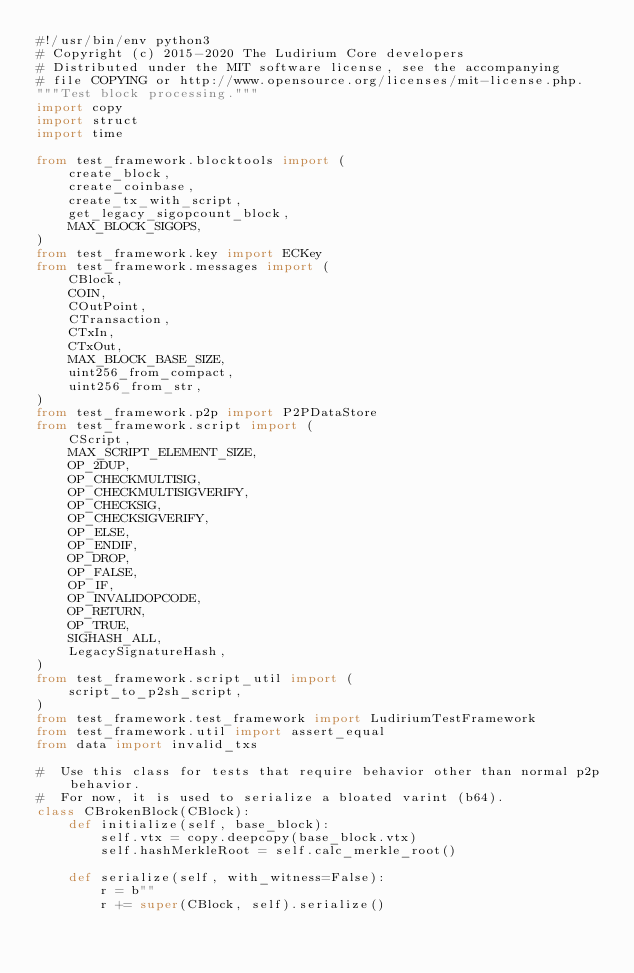<code> <loc_0><loc_0><loc_500><loc_500><_Python_>#!/usr/bin/env python3
# Copyright (c) 2015-2020 The Ludirium Core developers
# Distributed under the MIT software license, see the accompanying
# file COPYING or http://www.opensource.org/licenses/mit-license.php.
"""Test block processing."""
import copy
import struct
import time

from test_framework.blocktools import (
    create_block,
    create_coinbase,
    create_tx_with_script,
    get_legacy_sigopcount_block,
    MAX_BLOCK_SIGOPS,
)
from test_framework.key import ECKey
from test_framework.messages import (
    CBlock,
    COIN,
    COutPoint,
    CTransaction,
    CTxIn,
    CTxOut,
    MAX_BLOCK_BASE_SIZE,
    uint256_from_compact,
    uint256_from_str,
)
from test_framework.p2p import P2PDataStore
from test_framework.script import (
    CScript,
    MAX_SCRIPT_ELEMENT_SIZE,
    OP_2DUP,
    OP_CHECKMULTISIG,
    OP_CHECKMULTISIGVERIFY,
    OP_CHECKSIG,
    OP_CHECKSIGVERIFY,
    OP_ELSE,
    OP_ENDIF,
    OP_DROP,
    OP_FALSE,
    OP_IF,
    OP_INVALIDOPCODE,
    OP_RETURN,
    OP_TRUE,
    SIGHASH_ALL,
    LegacySignatureHash,
)
from test_framework.script_util import (
    script_to_p2sh_script,
)
from test_framework.test_framework import LudiriumTestFramework
from test_framework.util import assert_equal
from data import invalid_txs

#  Use this class for tests that require behavior other than normal p2p behavior.
#  For now, it is used to serialize a bloated varint (b64).
class CBrokenBlock(CBlock):
    def initialize(self, base_block):
        self.vtx = copy.deepcopy(base_block.vtx)
        self.hashMerkleRoot = self.calc_merkle_root()

    def serialize(self, with_witness=False):
        r = b""
        r += super(CBlock, self).serialize()</code> 